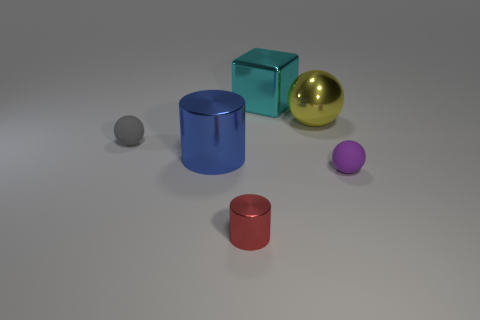There is a small sphere that is on the left side of the small matte thing to the right of the large yellow metallic thing behind the tiny red metallic object; what is its material?
Your answer should be compact. Rubber. What number of cylinders are there?
Provide a succinct answer. 2. What number of yellow objects are either large metal cylinders or shiny spheres?
Your answer should be compact. 1. What number of other objects are there of the same shape as the big yellow object?
Ensure brevity in your answer.  2. Is the color of the tiny matte thing that is in front of the big blue cylinder the same as the metallic object that is to the right of the cyan thing?
Give a very brief answer. No. What number of large things are metallic cubes or yellow shiny things?
Keep it short and to the point. 2. The gray object that is the same shape as the large yellow metallic thing is what size?
Provide a short and direct response. Small. There is a thing that is in front of the small matte thing to the right of the gray matte ball; what is it made of?
Keep it short and to the point. Metal. How many rubber objects are either blue objects or big things?
Give a very brief answer. 0. There is another rubber object that is the same shape as the small gray rubber thing; what is its color?
Provide a short and direct response. Purple. 